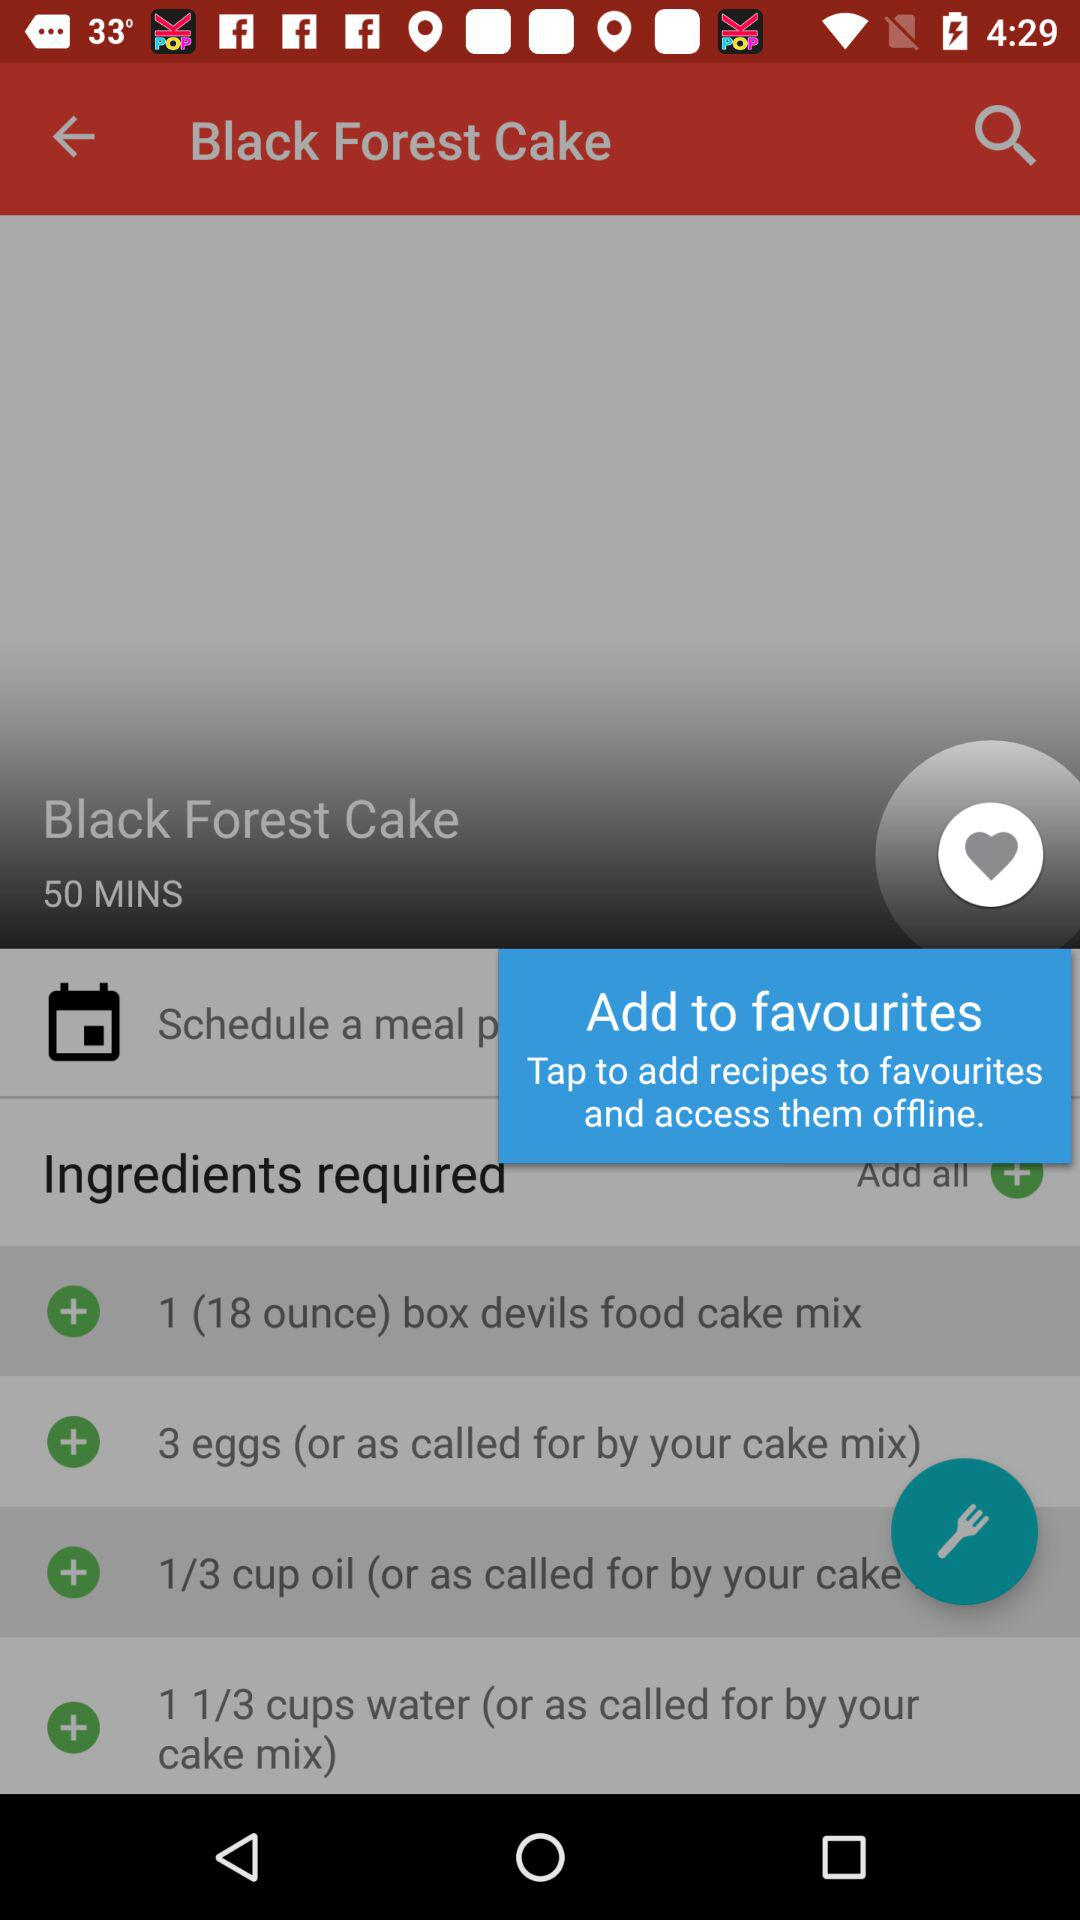Which brand of food cake mix is used?
When the provided information is insufficient, respond with <no answer>. <no answer> 